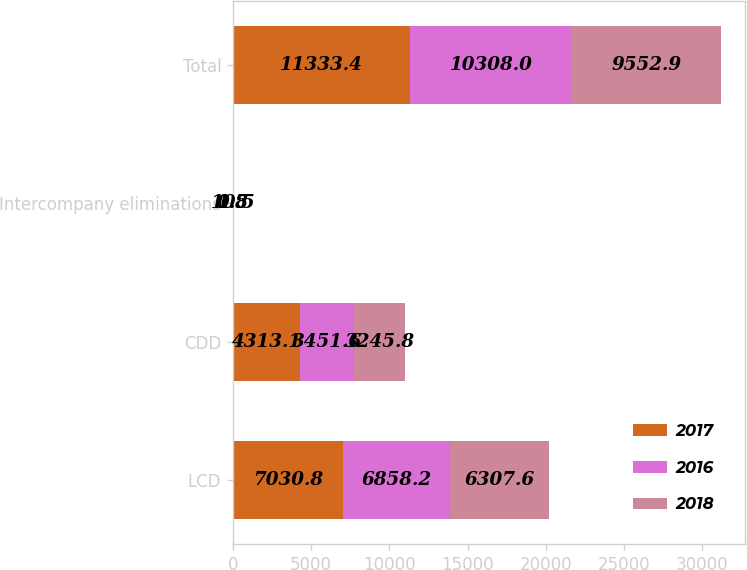Convert chart to OTSL. <chart><loc_0><loc_0><loc_500><loc_500><stacked_bar_chart><ecel><fcel>LCD<fcel>CDD<fcel>Intercompany eliminations<fcel>Total<nl><fcel>2017<fcel>7030.8<fcel>4313.1<fcel>10.5<fcel>11333.4<nl><fcel>2016<fcel>6858.2<fcel>3451.6<fcel>1.8<fcel>10308<nl><fcel>2018<fcel>6307.6<fcel>3245.8<fcel>0.5<fcel>9552.9<nl></chart> 